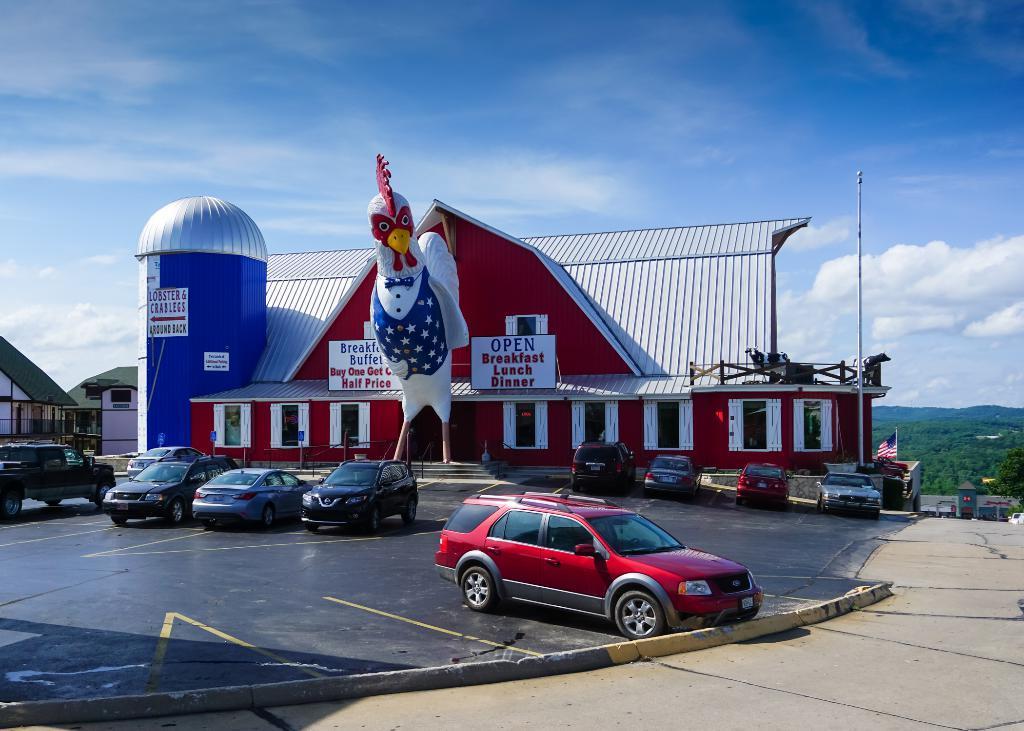Can you describe this image briefly? In this image we can see the buildings. On the building we can see boards with text. In front of the boards we can see a pole and vehicles. On the right side, we can see the trees and mountains. At the top we can see the sky. 